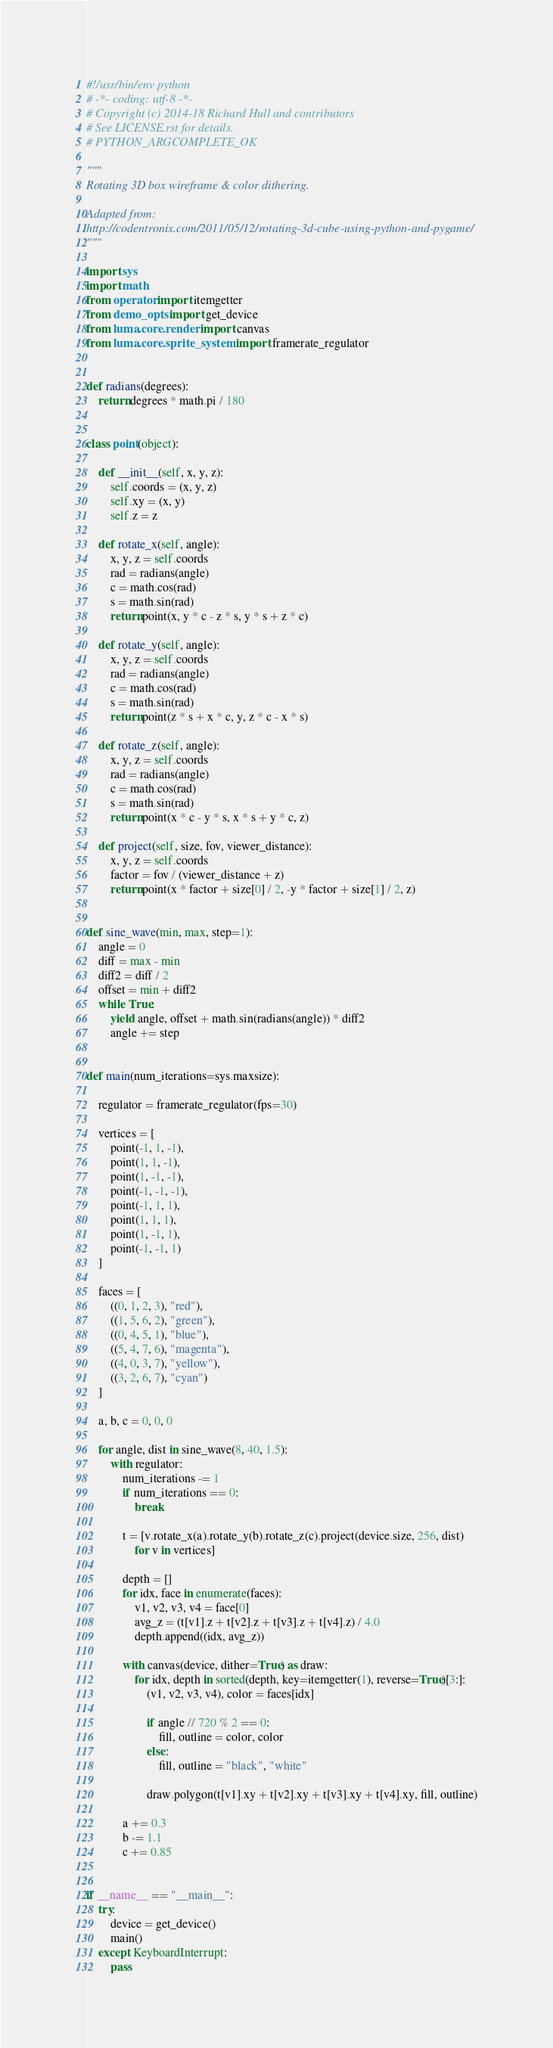Convert code to text. <code><loc_0><loc_0><loc_500><loc_500><_Python_>#!/usr/bin/env python
# -*- coding: utf-8 -*-
# Copyright (c) 2014-18 Richard Hull and contributors
# See LICENSE.rst for details.
# PYTHON_ARGCOMPLETE_OK

"""
Rotating 3D box wireframe & color dithering.

Adapted from:
http://codentronix.com/2011/05/12/rotating-3d-cube-using-python-and-pygame/
"""

import sys
import math
from operator import itemgetter
from demo_opts import get_device
from luma.core.render import canvas
from luma.core.sprite_system import framerate_regulator


def radians(degrees):
    return degrees * math.pi / 180


class point(object):

    def __init__(self, x, y, z):
        self.coords = (x, y, z)
        self.xy = (x, y)
        self.z = z

    def rotate_x(self, angle):
        x, y, z = self.coords
        rad = radians(angle)
        c = math.cos(rad)
        s = math.sin(rad)
        return point(x, y * c - z * s, y * s + z * c)

    def rotate_y(self, angle):
        x, y, z = self.coords
        rad = radians(angle)
        c = math.cos(rad)
        s = math.sin(rad)
        return point(z * s + x * c, y, z * c - x * s)

    def rotate_z(self, angle):
        x, y, z = self.coords
        rad = radians(angle)
        c = math.cos(rad)
        s = math.sin(rad)
        return point(x * c - y * s, x * s + y * c, z)

    def project(self, size, fov, viewer_distance):
        x, y, z = self.coords
        factor = fov / (viewer_distance + z)
        return point(x * factor + size[0] / 2, -y * factor + size[1] / 2, z)


def sine_wave(min, max, step=1):
    angle = 0
    diff = max - min
    diff2 = diff / 2
    offset = min + diff2
    while True:
        yield angle, offset + math.sin(radians(angle)) * diff2
        angle += step


def main(num_iterations=sys.maxsize):

    regulator = framerate_regulator(fps=30)

    vertices = [
        point(-1, 1, -1),
        point(1, 1, -1),
        point(1, -1, -1),
        point(-1, -1, -1),
        point(-1, 1, 1),
        point(1, 1, 1),
        point(1, -1, 1),
        point(-1, -1, 1)
    ]

    faces = [
        ((0, 1, 2, 3), "red"),
        ((1, 5, 6, 2), "green"),
        ((0, 4, 5, 1), "blue"),
        ((5, 4, 7, 6), "magenta"),
        ((4, 0, 3, 7), "yellow"),
        ((3, 2, 6, 7), "cyan")
    ]

    a, b, c = 0, 0, 0

    for angle, dist in sine_wave(8, 40, 1.5):
        with regulator:
            num_iterations -= 1
            if num_iterations == 0:
                break

            t = [v.rotate_x(a).rotate_y(b).rotate_z(c).project(device.size, 256, dist)
                for v in vertices]

            depth = []
            for idx, face in enumerate(faces):
                v1, v2, v3, v4 = face[0]
                avg_z = (t[v1].z + t[v2].z + t[v3].z + t[v4].z) / 4.0
                depth.append((idx, avg_z))

            with canvas(device, dither=True) as draw:
                for idx, depth in sorted(depth, key=itemgetter(1), reverse=True)[3:]:
                    (v1, v2, v3, v4), color = faces[idx]

                    if angle // 720 % 2 == 0:
                        fill, outline = color, color
                    else:
                        fill, outline = "black", "white"

                    draw.polygon(t[v1].xy + t[v2].xy + t[v3].xy + t[v4].xy, fill, outline)

            a += 0.3
            b -= 1.1
            c += 0.85


if __name__ == "__main__":
    try:
        device = get_device()
        main()
    except KeyboardInterrupt:
        pass
</code> 